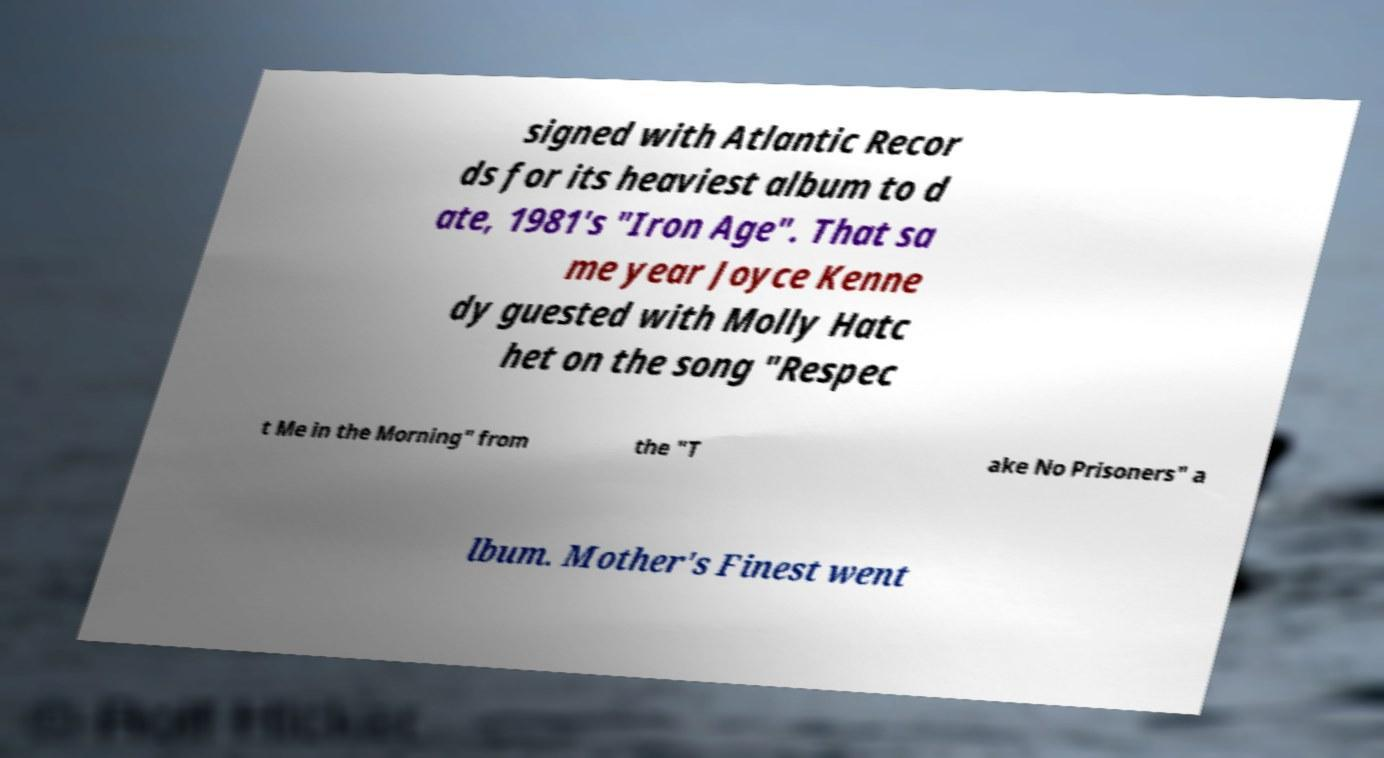Can you read and provide the text displayed in the image?This photo seems to have some interesting text. Can you extract and type it out for me? signed with Atlantic Recor ds for its heaviest album to d ate, 1981's "Iron Age". That sa me year Joyce Kenne dy guested with Molly Hatc het on the song "Respec t Me in the Morning" from the "T ake No Prisoners" a lbum. Mother's Finest went 